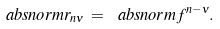Convert formula to latex. <formula><loc_0><loc_0><loc_500><loc_500>\ a b s n o r m { r _ { n \nu } } \, = \, \ a b s n o r m { f ^ { n - \nu } } .</formula> 